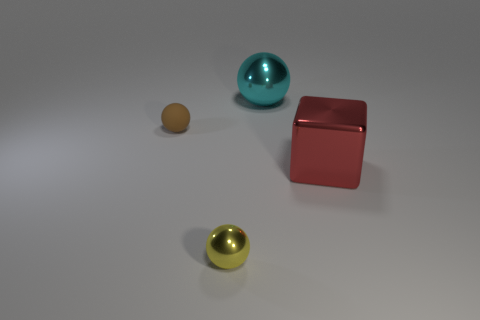How many big cyan metallic things are there?
Your answer should be compact. 1. The block that is the same size as the cyan metal sphere is what color?
Your answer should be very brief. Red. Do the tiny sphere to the left of the tiny shiny thing and the sphere that is on the right side of the small metallic sphere have the same material?
Your response must be concise. No. What size is the metallic ball behind the thing that is on the left side of the small yellow thing?
Keep it short and to the point. Large. There is a sphere that is in front of the small brown object; what material is it?
Your answer should be very brief. Metal. What number of objects are things behind the large red object or metallic things that are in front of the cube?
Give a very brief answer. 3. There is a large thing that is the same shape as the tiny yellow metallic thing; what is it made of?
Your answer should be very brief. Metal. Is there a red cube of the same size as the yellow object?
Keep it short and to the point. No. The sphere that is both in front of the cyan sphere and behind the yellow thing is made of what material?
Your answer should be compact. Rubber. What number of matte things are big things or yellow cylinders?
Your response must be concise. 0. 